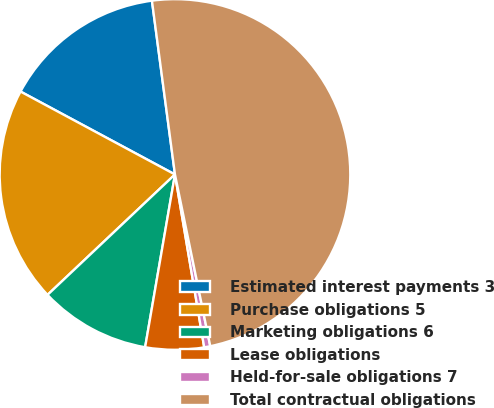Convert chart. <chart><loc_0><loc_0><loc_500><loc_500><pie_chart><fcel>Estimated interest payments 3<fcel>Purchase obligations 5<fcel>Marketing obligations 6<fcel>Lease obligations<fcel>Held-for-sale obligations 7<fcel>Total contractual obligations<nl><fcel>15.06%<fcel>19.89%<fcel>10.23%<fcel>5.39%<fcel>0.56%<fcel>48.87%<nl></chart> 